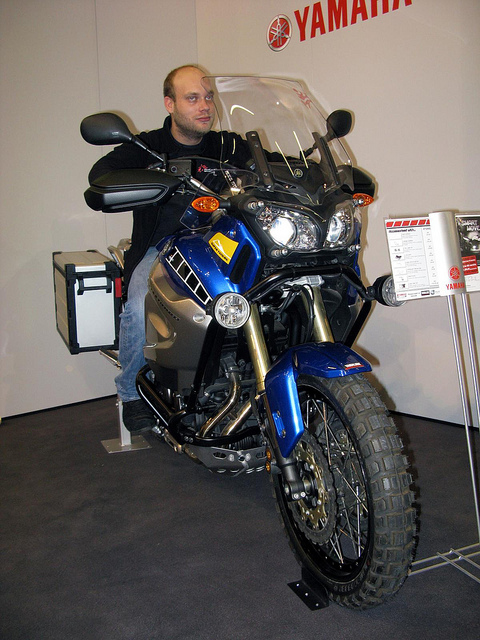<image>What is cast? I don't know what is cast. It can be a motorcycle, shadow, wheel, or man. What is cast? I don't know what a cast is. It can be either a motorcycle, a shadow, or a wheel. 